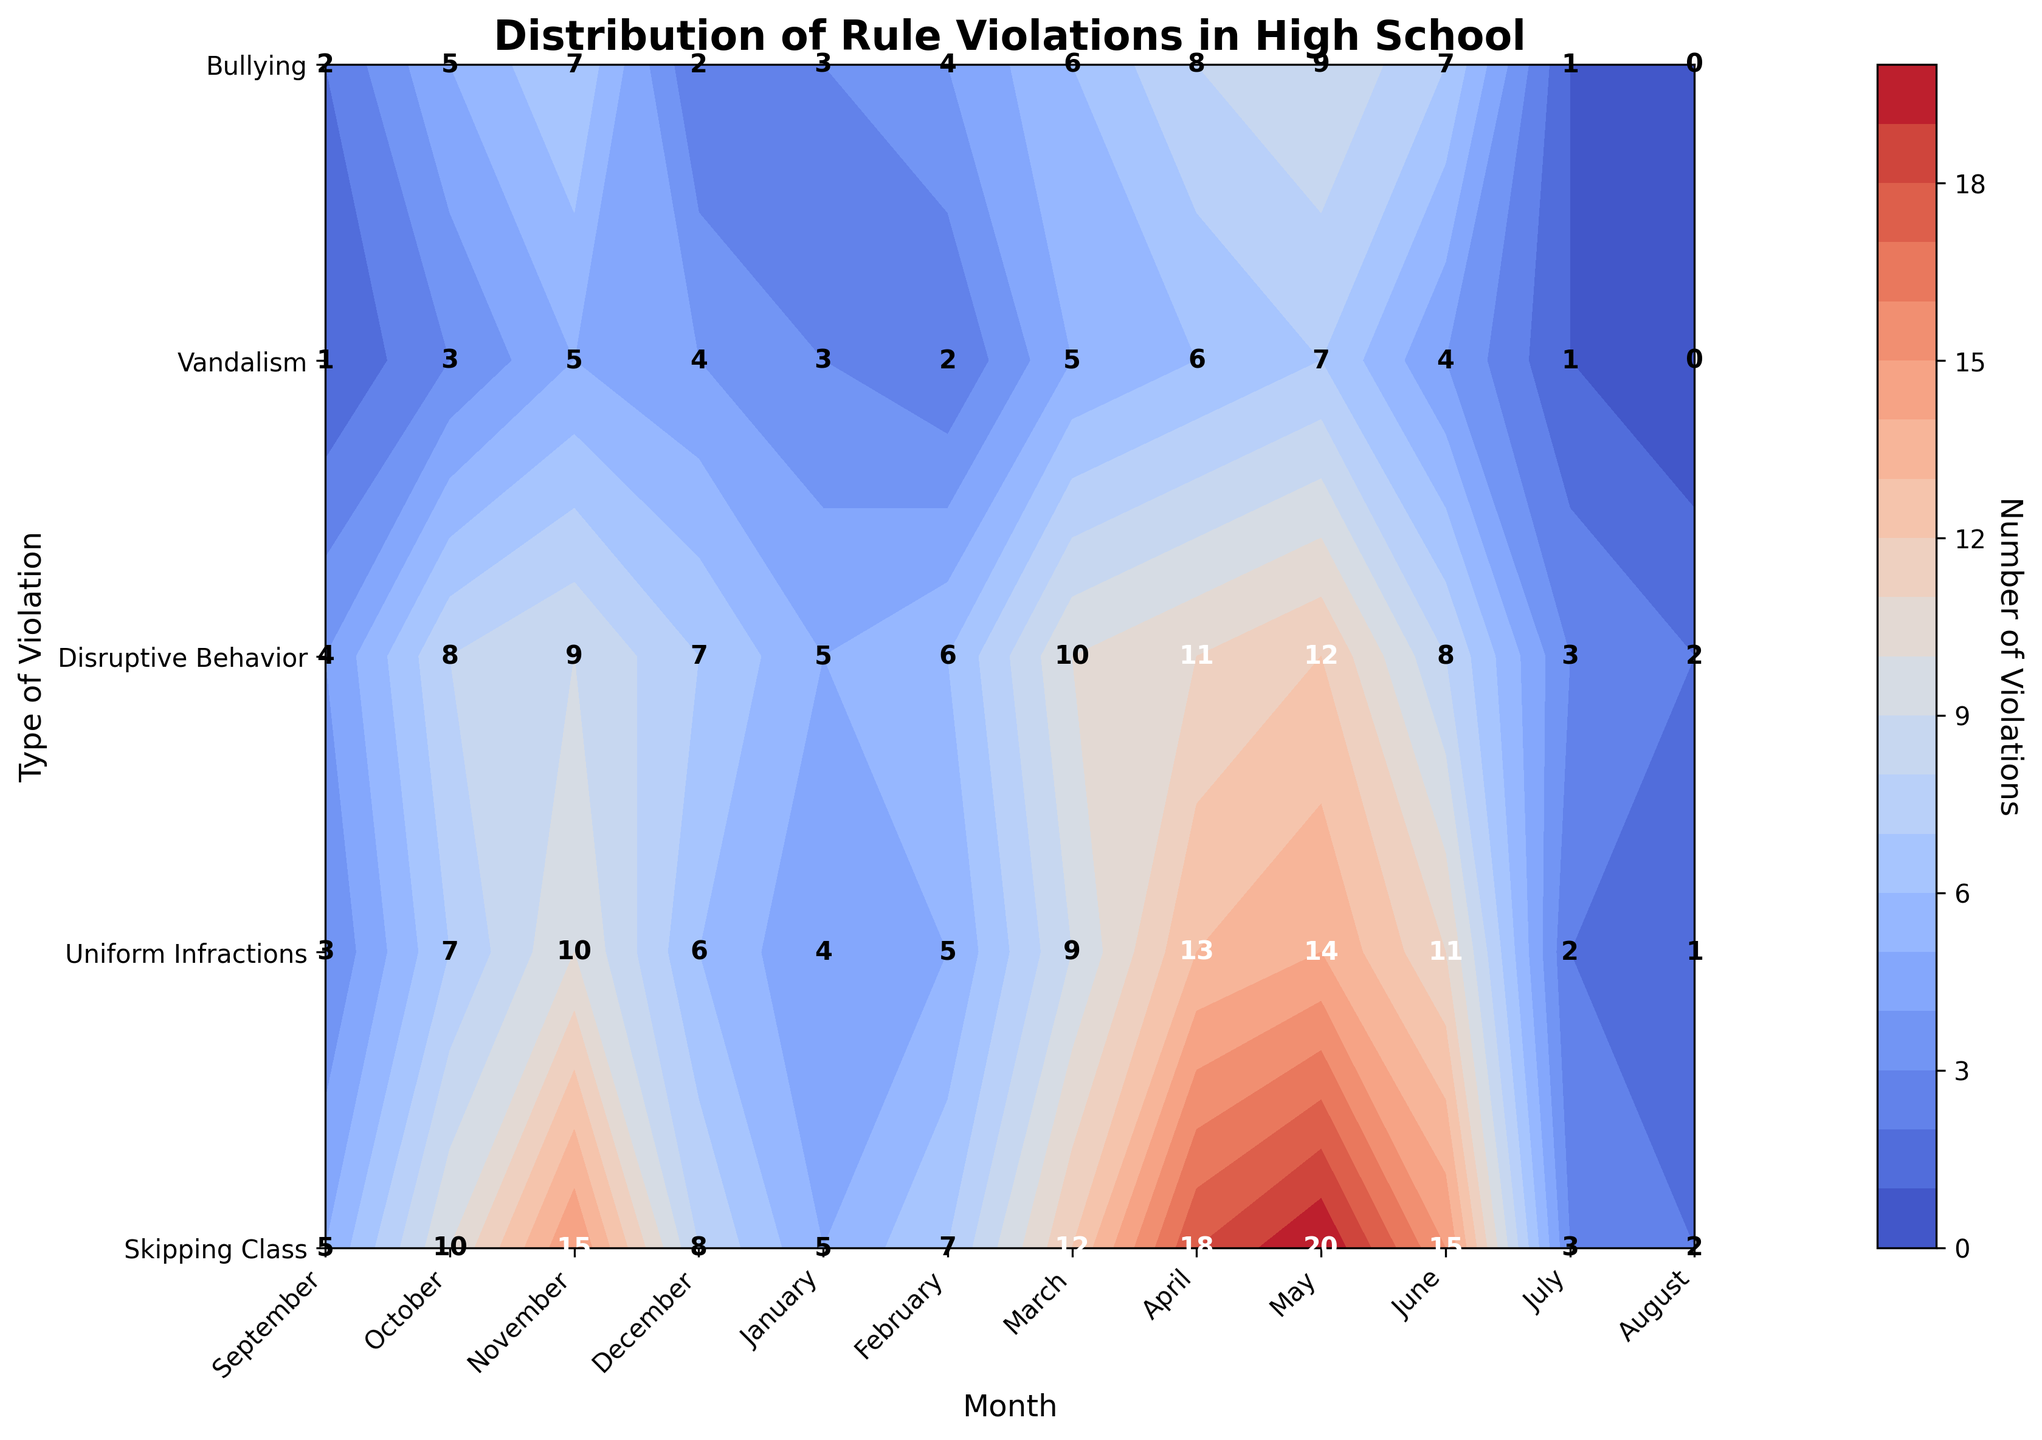What is the title of the figure? The title is the text at the top of the figure. It provides a summary of what the figure represents.
Answer: Distribution of Rule Violations in High School Which month has the highest number of skipping class incidents? Look at the contour plot for the Skipping Class row. Identify the month with the peak value.
Answer: May What type of rule violation has the highest number in April? Look at the April column and identify the row with the highest value.
Answer: Skipping Class During which months do Uniform Infractions exceed 10 incidents? Identify the months on the x-axis for the Uniform Infractions row where the corresponding values are higher than 10.
Answer: April, May, June What is the total number of Bullying incidents in the first quarter of the year? Sum the values for Bullying in January, February, and March. The values are 3, 4, and 6 respectively. So, 3 + 4 + 6 = 13.
Answer: 13 Which type of violation has the most consistent number of incidents throughout the year? Compare the variation of each type of rule violation across all months. Find the one with the smallest range.
Answer: Skipping Class How does the number of Vandalism incidents in January compare to September? Look at the values for Vandalism in January and September and find the difference. In September, there is 1 incident, and in January, there are 3. The difference is 3 - 1 = 2.
Answer: 2 more incidents in January What is the average number of Disruptive Behavior incidents from September to December? Sum the values of Disruptive Behavior for September, October, November, December. Then divide by 4. The values are 4, 8, 9, and 7, respectively. So, (4 + 8 + 9 + 7) / 4 = 28 / 4 = 7.
Answer: 7 Which month has the lowest number of total violations? Sum the values for all types of violations for each month and find the month with the smallest sum. In August, the total = (2 + 1 + 2 + 0 + 0) = 5. No other month has fewer incidents.
Answer: August 